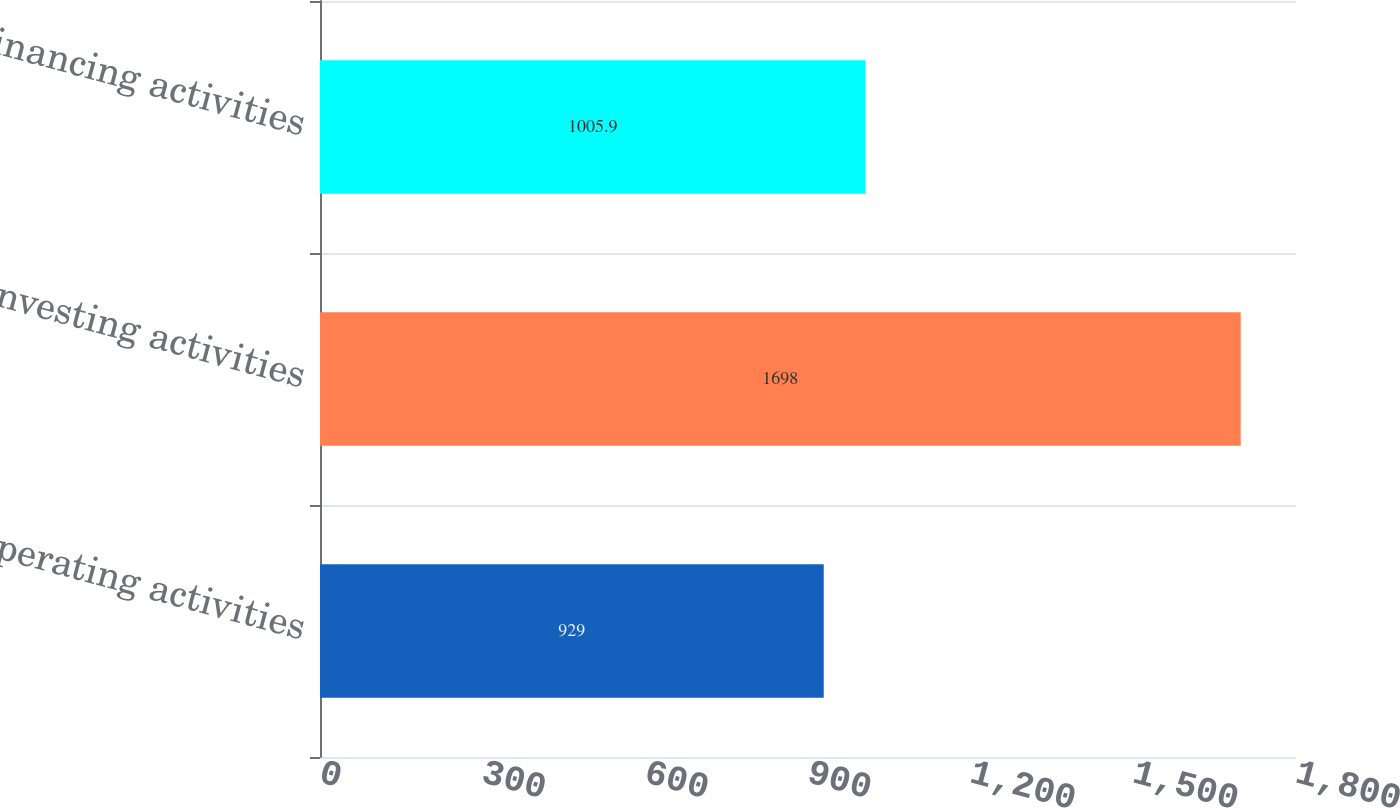<chart> <loc_0><loc_0><loc_500><loc_500><bar_chart><fcel>Operating activities<fcel>Investing activities<fcel>Financing activities<nl><fcel>929<fcel>1698<fcel>1005.9<nl></chart> 